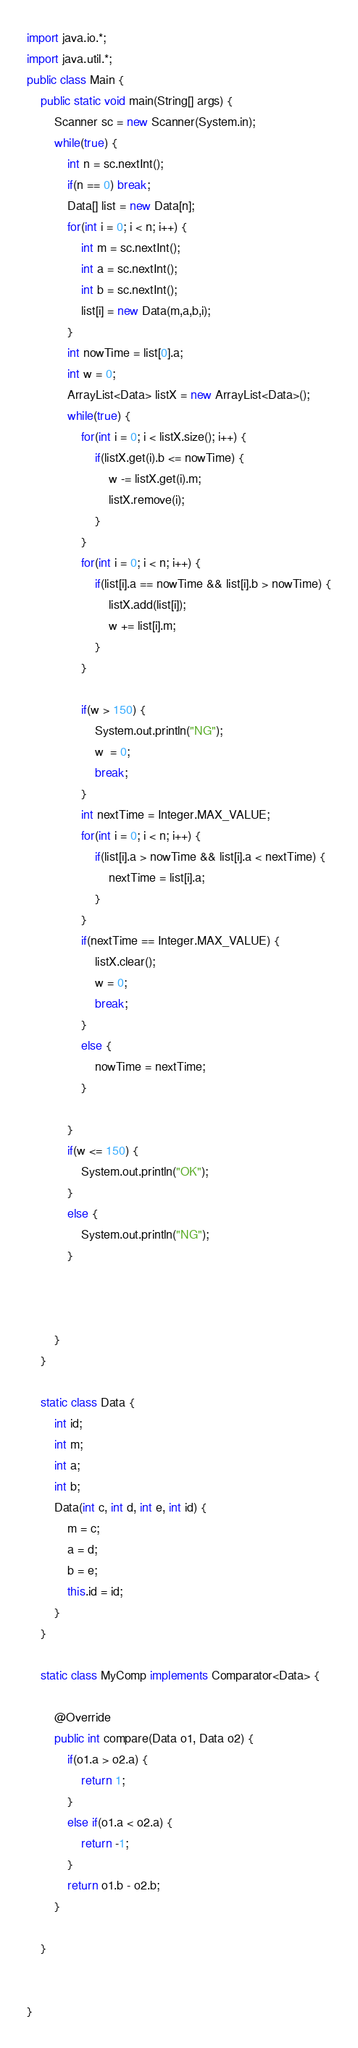Convert code to text. <code><loc_0><loc_0><loc_500><loc_500><_Java_>import java.io.*;
import java.util.*;
public class Main {
	public static void main(String[] args) {
		Scanner sc = new Scanner(System.in);
		while(true) {
			int n = sc.nextInt();
			if(n == 0) break;
			Data[] list = new Data[n];
			for(int i = 0; i < n; i++) {
				int m = sc.nextInt();
				int a = sc.nextInt();
				int b = sc.nextInt();
				list[i] = new Data(m,a,b,i);
			}
			int nowTime = list[0].a;
			int w = 0;
			ArrayList<Data> listX = new ArrayList<Data>();
			while(true) {
				for(int i = 0; i < listX.size(); i++) {
					if(listX.get(i).b <= nowTime) {
						w -= listX.get(i).m;
						listX.remove(i);
					}
				}
				for(int i = 0; i < n; i++) {
					if(list[i].a == nowTime && list[i].b > nowTime) {
						listX.add(list[i]);
						w += list[i].m;
					}
				}
				
				if(w > 150) {
					System.out.println("NG");
					w  = 0;
					break;
				}
				int nextTime = Integer.MAX_VALUE;
				for(int i = 0; i < n; i++) {
					if(list[i].a > nowTime && list[i].a < nextTime) {
						nextTime = list[i].a;
					}
				}
				if(nextTime == Integer.MAX_VALUE) {
					listX.clear();
					w = 0;
					break;
				}
				else {
					nowTime = nextTime;
				}
				
			}
			if(w <= 150) {
				System.out.println("OK");
			}
			else {
				System.out.println("NG");
			}
			
			
			
		}
	}
	
	static class Data {
		int id;
		int m;
		int a;
		int b;
		Data(int c, int d, int e, int id) {
			m = c;
			a = d;
			b = e;
			this.id = id;
		}
	}
	
	static class MyComp implements Comparator<Data> {

		@Override
		public int compare(Data o1, Data o2) {
			if(o1.a > o2.a) {
				return 1;
			}
			else if(o1.a < o2.a) {
				return -1;
			}
			return o1.b - o2.b;
		}
		
	}
	
		
}</code> 